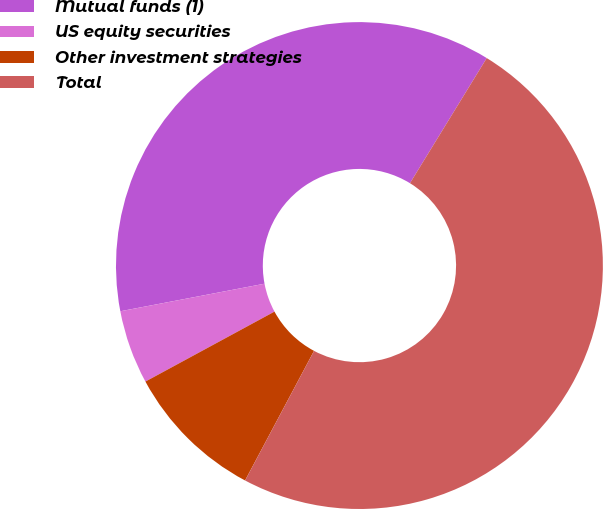Convert chart to OTSL. <chart><loc_0><loc_0><loc_500><loc_500><pie_chart><fcel>Mutual funds (1)<fcel>US equity securities<fcel>Other investment strategies<fcel>Total<nl><fcel>36.76%<fcel>4.9%<fcel>9.31%<fcel>49.02%<nl></chart> 